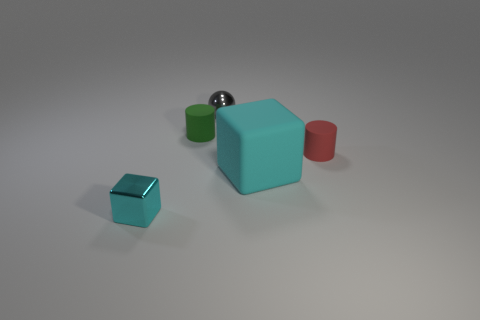Is there anything else that has the same shape as the red thing?
Provide a succinct answer. Yes. What is the color of the metal cube?
Keep it short and to the point. Cyan. How many brown shiny things are the same shape as the red thing?
Give a very brief answer. 0. There is a metal sphere that is the same size as the red object; what is its color?
Give a very brief answer. Gray. Are there any brown metal cubes?
Ensure brevity in your answer.  No. There is a metallic object that is behind the large cyan cube; what is its shape?
Give a very brief answer. Sphere. What number of cylinders are on the right side of the small sphere and to the left of the gray metallic sphere?
Your answer should be compact. 0. Are there any big cyan blocks that have the same material as the large cyan object?
Your response must be concise. No. There is another cube that is the same color as the matte cube; what size is it?
Make the answer very short. Small. How many spheres are tiny metal objects or red shiny objects?
Make the answer very short. 1. 